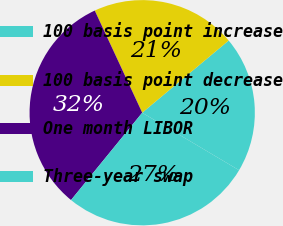<chart> <loc_0><loc_0><loc_500><loc_500><pie_chart><fcel>100 basis point increase<fcel>100 basis point decrease<fcel>One month LIBOR<fcel>Three-year swap<nl><fcel>19.59%<fcel>20.85%<fcel>32.19%<fcel>27.36%<nl></chart> 